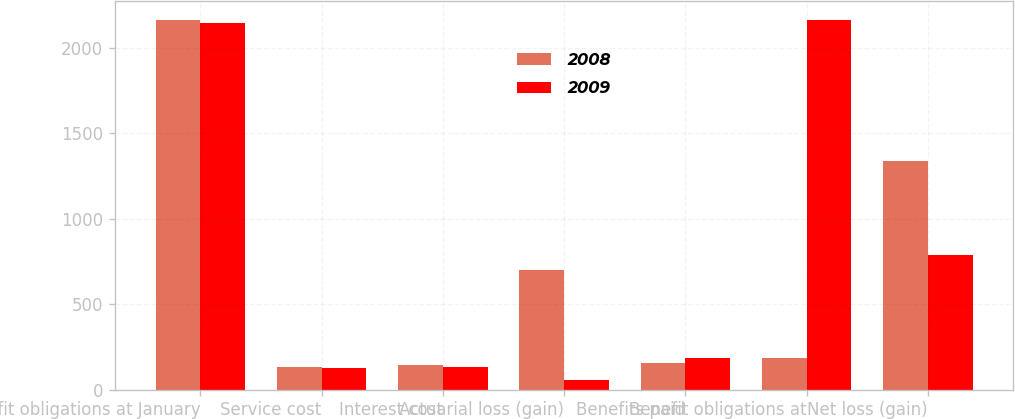Convert chart. <chart><loc_0><loc_0><loc_500><loc_500><stacked_bar_chart><ecel><fcel>Benefit obligations at January<fcel>Service cost<fcel>Interest cost<fcel>Actuarial loss (gain)<fcel>Benefits paid<fcel>Benefit obligations at<fcel>Net loss (gain)<nl><fcel>2008<fcel>2164<fcel>130<fcel>146<fcel>703<fcel>154<fcel>183<fcel>1338<nl><fcel>2009<fcel>2143<fcel>127<fcel>135<fcel>58<fcel>183<fcel>2164<fcel>785<nl></chart> 